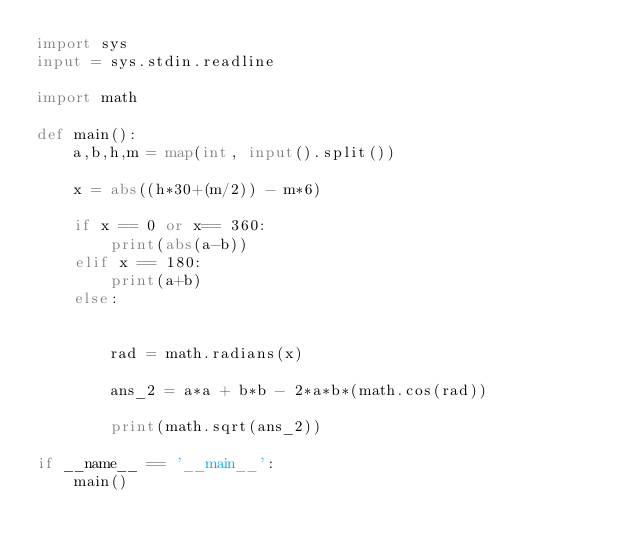<code> <loc_0><loc_0><loc_500><loc_500><_Python_>import sys
input = sys.stdin.readline

import math

def main():
    a,b,h,m = map(int, input().split())

    x = abs((h*30+(m/2)) - m*6)

    if x == 0 or x== 360:
        print(abs(a-b))
    elif x == 180:
        print(a+b)
    else:


        rad = math.radians(x)

        ans_2 = a*a + b*b - 2*a*b*(math.cos(rad))

        print(math.sqrt(ans_2))

if __name__ == '__main__':
    main()
</code> 